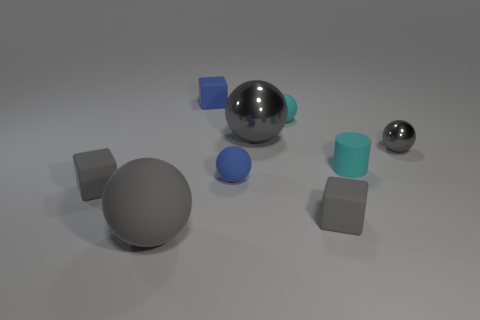What is the material of the small gray object that is to the right of the big gray matte object and to the left of the small matte cylinder?
Ensure brevity in your answer.  Rubber. Are any big metal balls visible?
Provide a short and direct response. Yes. What is the shape of the cyan thing that is the same material as the small cyan sphere?
Offer a very short reply. Cylinder. Does the large gray metallic object have the same shape as the large gray object that is left of the small blue matte block?
Make the answer very short. Yes. There is a cyan thing that is in front of the cyan matte thing behind the cyan cylinder; what is it made of?
Offer a terse response. Rubber. What number of other things are there of the same shape as the big gray matte thing?
Offer a terse response. 4. There is a tiny blue object left of the blue ball; does it have the same shape as the matte object to the left of the large matte ball?
Provide a short and direct response. Yes. What is the blue ball made of?
Your answer should be compact. Rubber. There is a gray ball to the right of the big metal ball; what material is it?
Offer a very short reply. Metal. There is a blue block that is made of the same material as the small cyan sphere; what size is it?
Give a very brief answer. Small. 